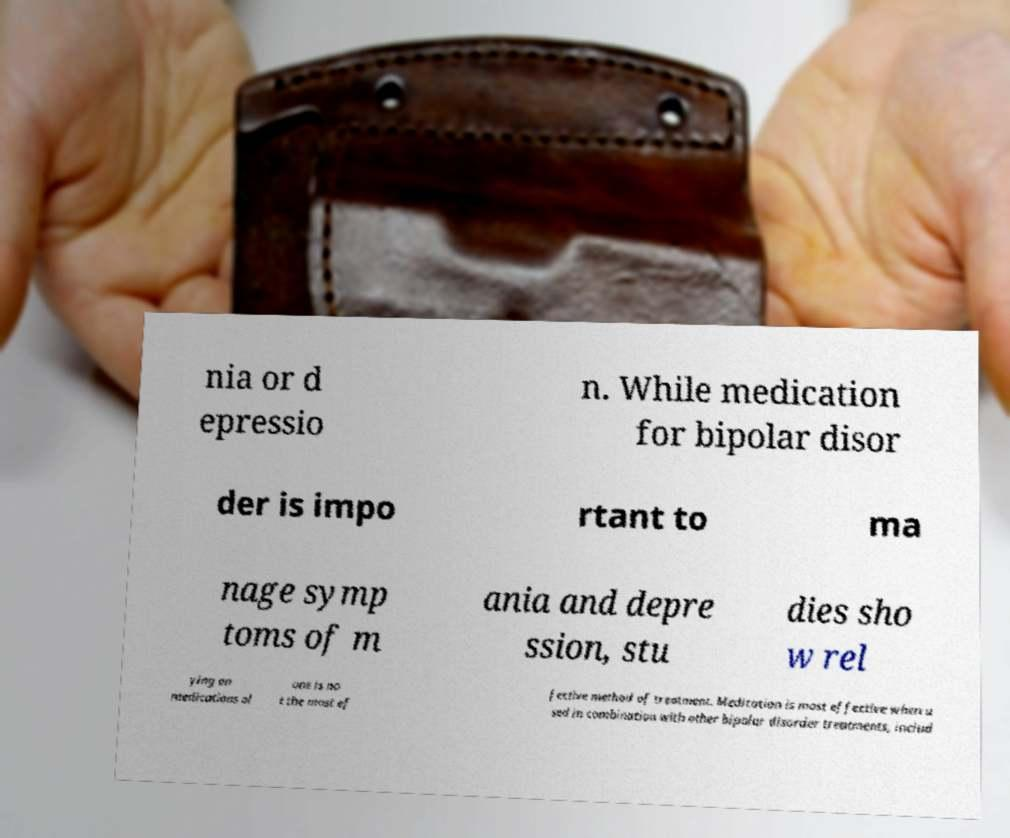Can you read and provide the text displayed in the image?This photo seems to have some interesting text. Can you extract and type it out for me? nia or d epressio n. While medication for bipolar disor der is impo rtant to ma nage symp toms of m ania and depre ssion, stu dies sho w rel ying on medications al one is no t the most ef fective method of treatment. Medication is most effective when u sed in combination with other bipolar disorder treatments, includ 